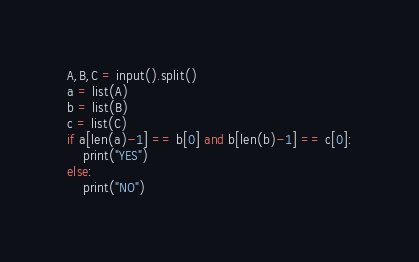<code> <loc_0><loc_0><loc_500><loc_500><_Python_>A,B,C = input().split()
a = list(A)
b = list(B)
c = list(C)
if a[len(a)-1] == b[0] and b[len(b)-1] == c[0]:
    print("YES")
else:
    print("NO")
</code> 